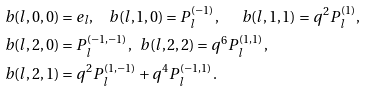Convert formula to latex. <formula><loc_0><loc_0><loc_500><loc_500>b ( l , 0 , 0 ) & = e _ { l } , \quad b ( l , 1 , 0 ) = P _ { l } ^ { ( - 1 ) } , \quad \ \ b ( l , 1 , 1 ) = q ^ { 2 } P _ { l } ^ { ( 1 ) } , \\ b ( l , 2 , 0 ) & = P _ { l } ^ { ( - 1 , - 1 ) } , \ \ b ( l , 2 , 2 ) = q ^ { 6 } P _ { l } ^ { ( 1 , 1 ) } , \\ b ( l , 2 , 1 ) & = q ^ { 2 } P _ { l } ^ { ( 1 , - 1 ) } + q ^ { 4 } P _ { l } ^ { ( - 1 , 1 ) } .</formula> 